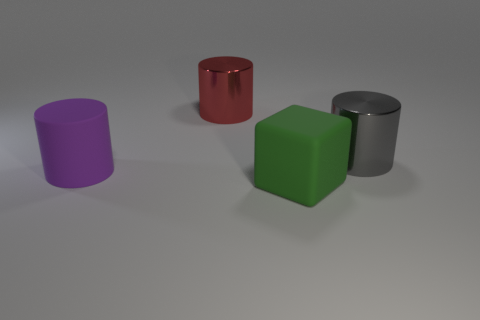Is the green matte object the same size as the red shiny thing?
Your answer should be compact. Yes. Is the material of the purple thing the same as the red cylinder?
Provide a succinct answer. No. There is a rubber thing that is the same size as the purple cylinder; what is its shape?
Make the answer very short. Cube. Is the number of large rubber objects greater than the number of big things?
Ensure brevity in your answer.  No. What is the material of the object that is left of the gray thing and on the right side of the large red shiny cylinder?
Offer a very short reply. Rubber. What number of other things are there of the same material as the gray object
Provide a short and direct response. 1. What number of matte things are either purple objects or large cubes?
Give a very brief answer. 2. There is a red metallic object; is its shape the same as the large purple matte object in front of the large red thing?
Provide a succinct answer. Yes. Is the number of large purple cylinders to the right of the green rubber cube greater than the number of objects in front of the big red cylinder?
Your answer should be compact. No. There is a big metallic cylinder that is to the left of the shiny cylinder that is right of the large block; is there a large matte cylinder in front of it?
Your answer should be compact. Yes. 